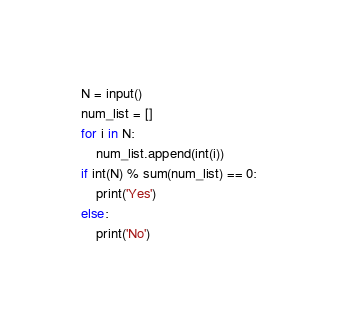<code> <loc_0><loc_0><loc_500><loc_500><_Python_>N = input()
num_list = []
for i in N:
    num_list.append(int(i))
if int(N) % sum(num_list) == 0:
    print('Yes')
else:
    print('No')</code> 